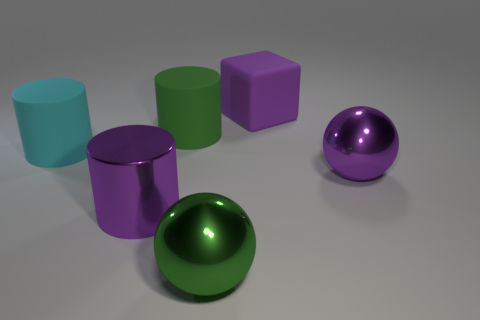Add 1 tiny yellow shiny things. How many objects exist? 7 Subtract all blocks. How many objects are left? 5 Add 6 large cyan things. How many large cyan things are left? 7 Add 5 big purple metallic cylinders. How many big purple metallic cylinders exist? 6 Subtract 0 yellow cylinders. How many objects are left? 6 Subtract all metallic things. Subtract all large metal cylinders. How many objects are left? 2 